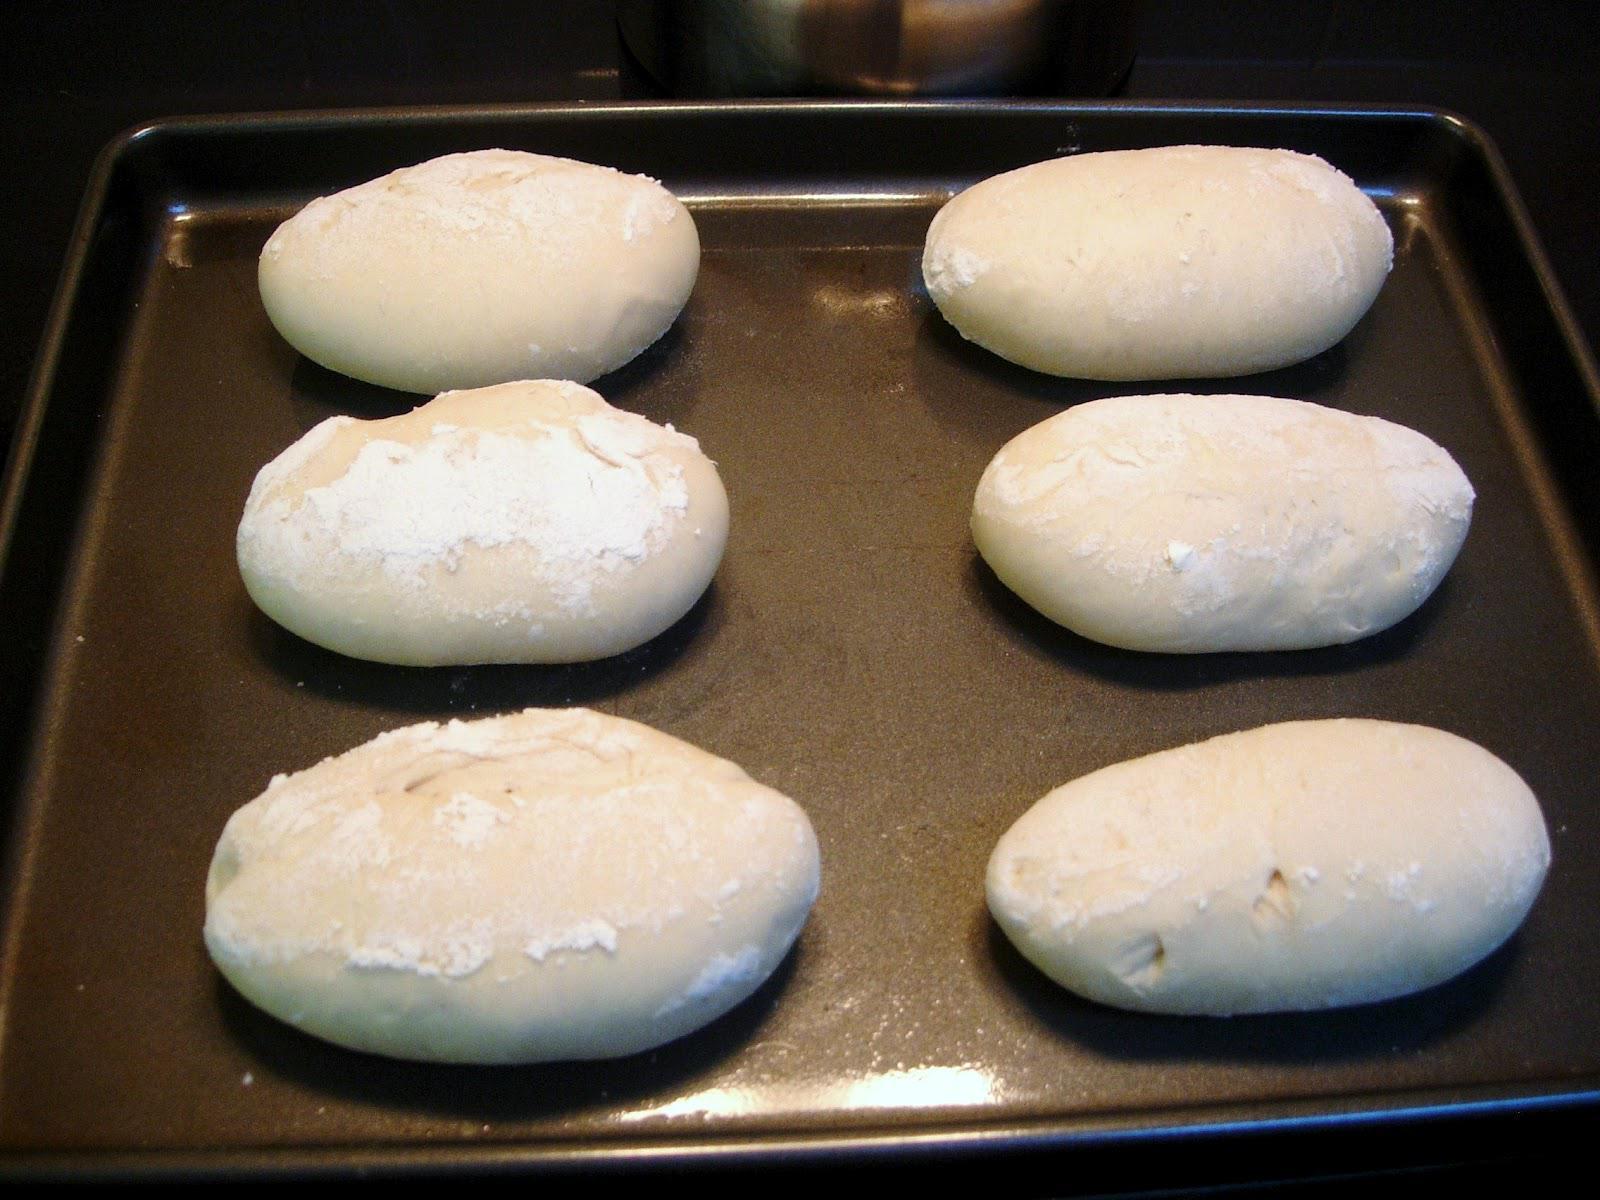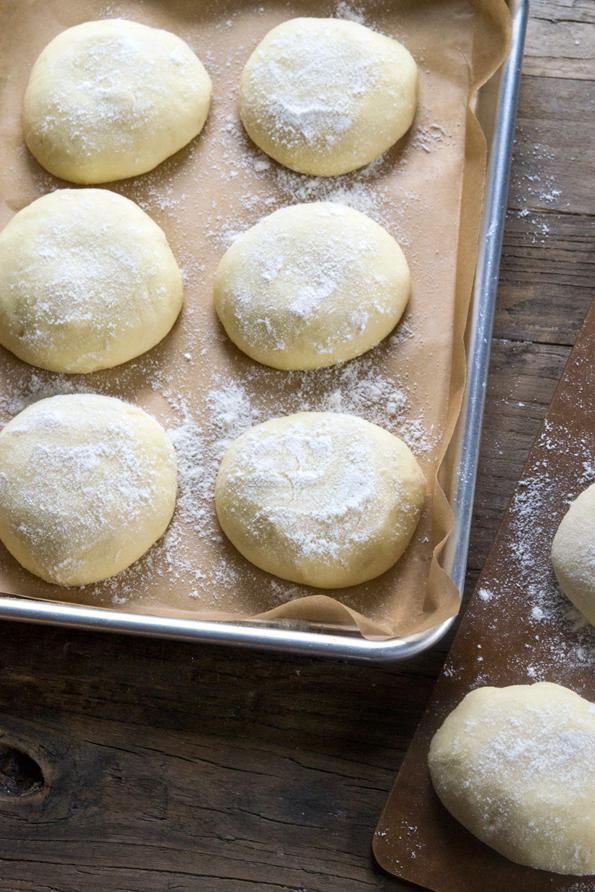The first image is the image on the left, the second image is the image on the right. Assess this claim about the two images: "there are 6 balls of bread dough in a silver pan lined with parchment paper". Correct or not? Answer yes or no. Yes. The first image is the image on the left, the second image is the image on the right. Considering the images on both sides, is "One pan of dough has at least sixteen balls, and all pans have balls that are touching and not spaced out." valid? Answer yes or no. No. 